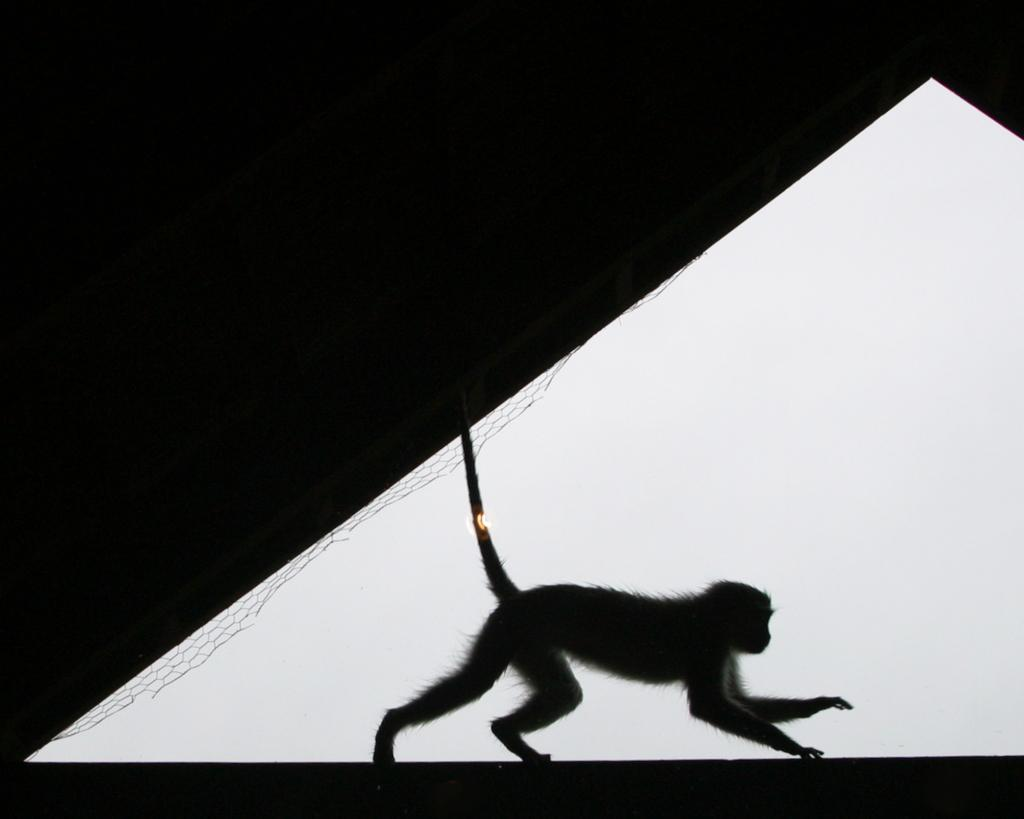What animal is present in the image? There is a monkey in the image. What is the monkey doing in the image? The monkey is walking on a wall. What object can be seen in the image besides the monkey? There is a net in the image. How would you describe the overall lighting in the image? The background of the image is dark. What kind of trouble is the man causing in the image? There is no man present in the image, so it's not possible to determine if anyone is causing trouble. 